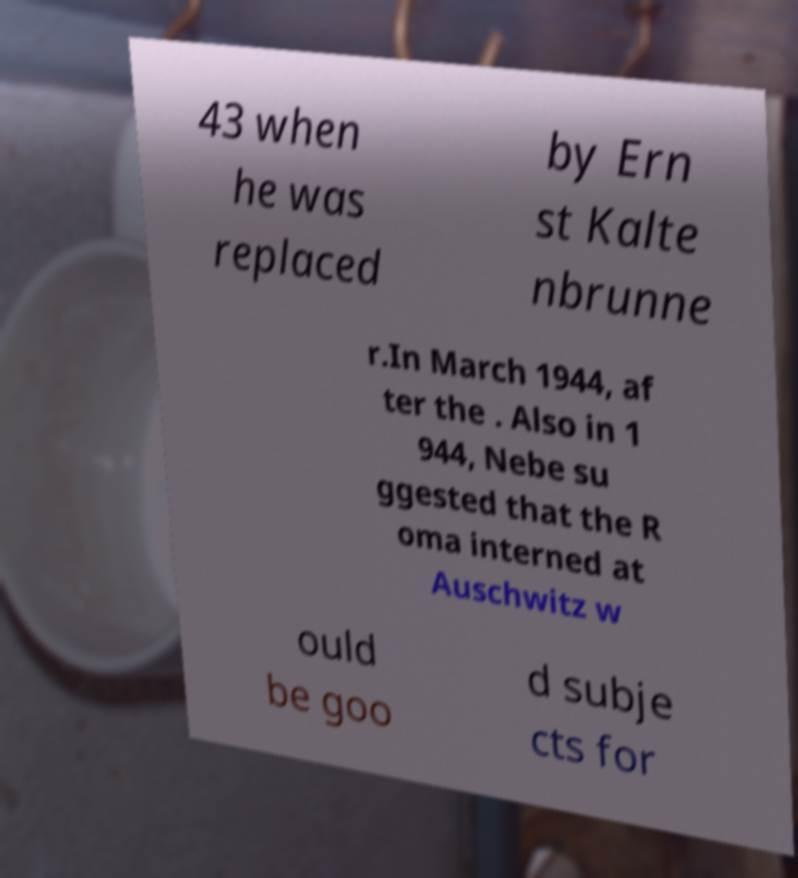Could you assist in decoding the text presented in this image and type it out clearly? 43 when he was replaced by Ern st Kalte nbrunne r.In March 1944, af ter the . Also in 1 944, Nebe su ggested that the R oma interned at Auschwitz w ould be goo d subje cts for 